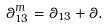Convert formula to latex. <formula><loc_0><loc_0><loc_500><loc_500>\theta _ { 1 3 } ^ { m } = \theta _ { 1 3 } + \theta .</formula> 